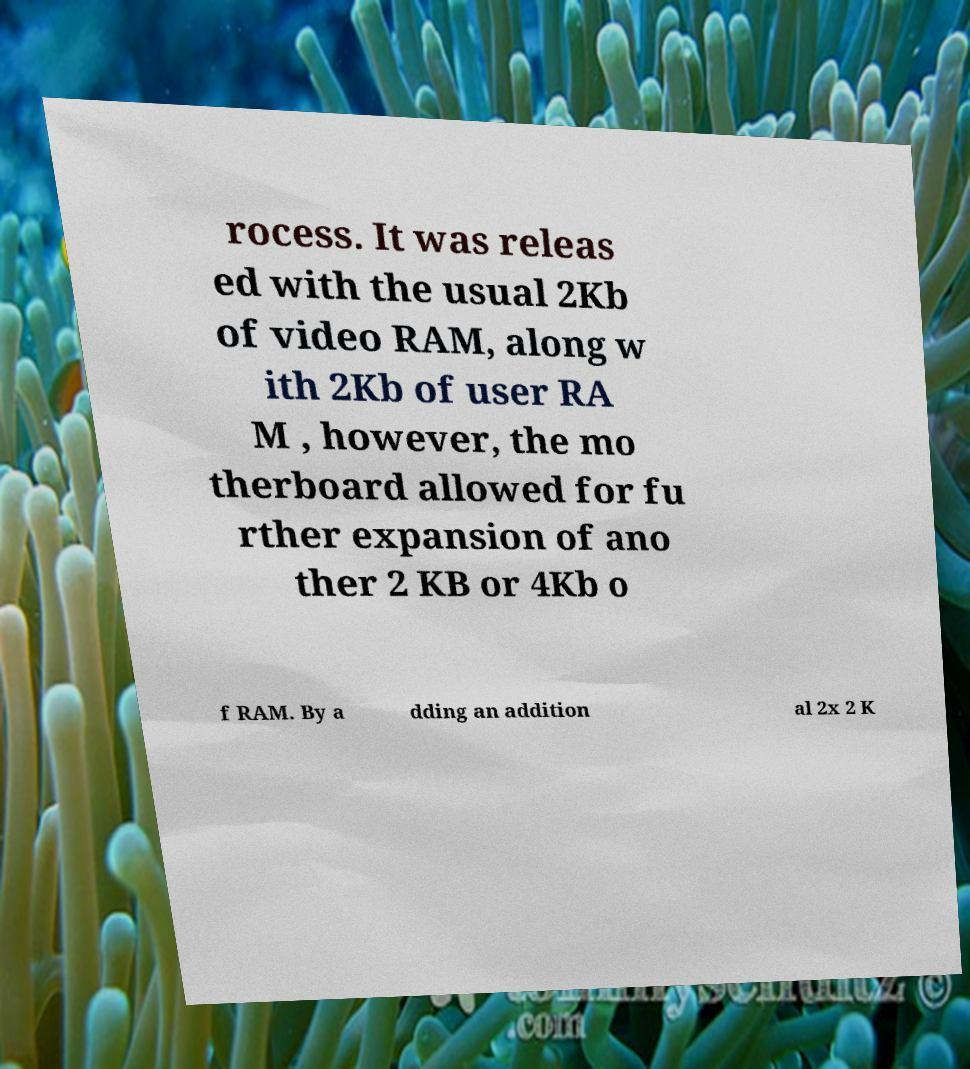Please identify and transcribe the text found in this image. rocess. It was releas ed with the usual 2Kb of video RAM, along w ith 2Kb of user RA M , however, the mo therboard allowed for fu rther expansion of ano ther 2 KB or 4Kb o f RAM. By a dding an addition al 2x 2 K 